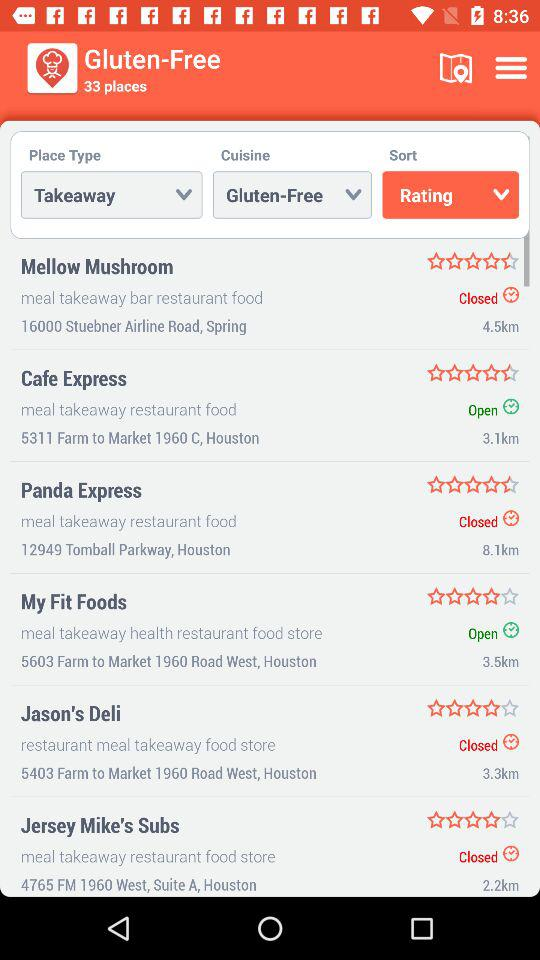How far is "Cafe Express"? "Cafe Express" is 3.1 km away. 